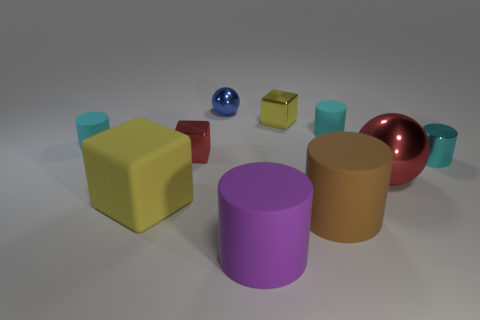What is the shape of the small object that is the same color as the large cube?
Give a very brief answer. Cube. The big object left of the blue metallic thing that is right of the small red object is made of what material?
Provide a succinct answer. Rubber. Is there a large cylinder of the same color as the big cube?
Ensure brevity in your answer.  No. What is the size of the purple cylinder that is made of the same material as the large yellow object?
Provide a succinct answer. Large. Are there any other things that have the same color as the big matte block?
Provide a succinct answer. Yes. There is a small cylinder in front of the small red cube; what is its color?
Keep it short and to the point. Cyan. There is a tiny matte cylinder on the right side of the small cylinder that is to the left of the yellow metallic block; are there any tiny matte things behind it?
Keep it short and to the point. No. Is the number of cyan things in front of the matte cube greater than the number of red matte cylinders?
Give a very brief answer. No. There is a red metallic object to the left of the tiny yellow metallic object; does it have the same shape as the brown thing?
Offer a very short reply. No. Are there any other things that are made of the same material as the blue sphere?
Provide a succinct answer. Yes. 